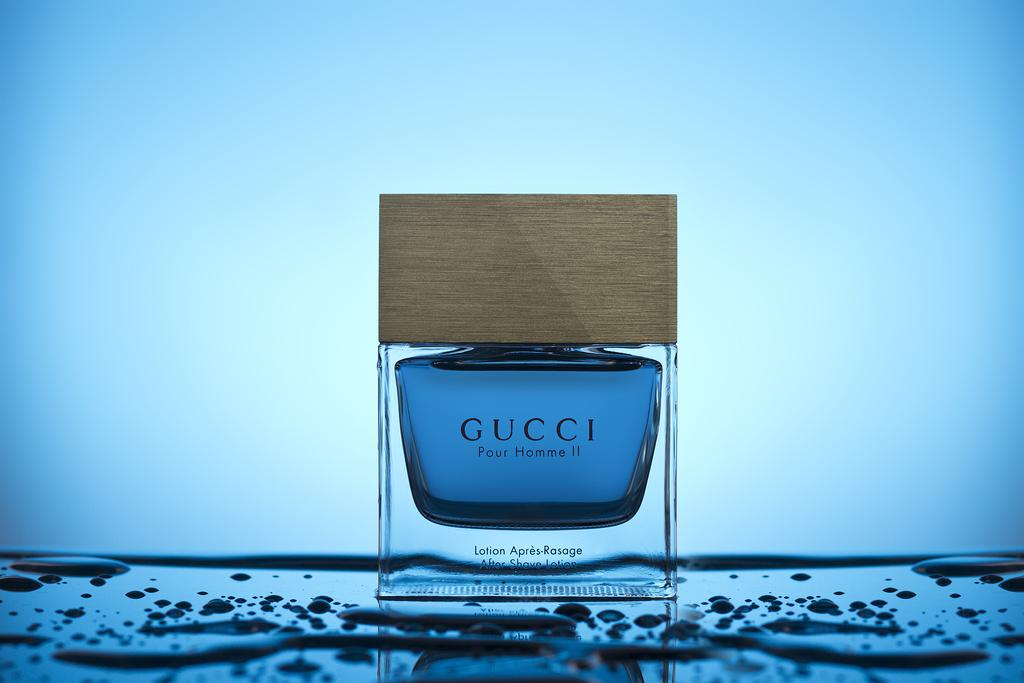Provide a one-sentence caption for the provided image. An advertisement for a cologne from the Gucci brand. 